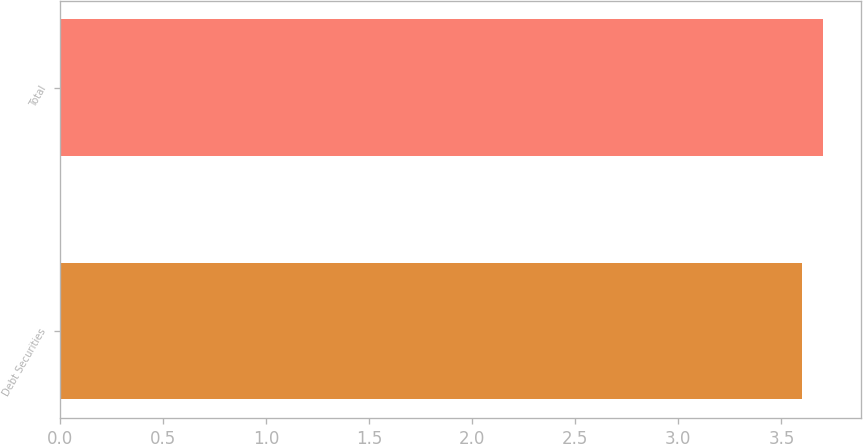<chart> <loc_0><loc_0><loc_500><loc_500><bar_chart><fcel>Debt Securities<fcel>Total<nl><fcel>3.6<fcel>3.7<nl></chart> 